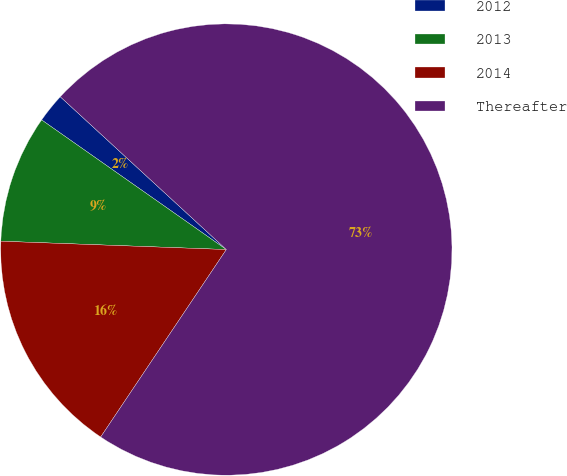Convert chart. <chart><loc_0><loc_0><loc_500><loc_500><pie_chart><fcel>2012<fcel>2013<fcel>2014<fcel>Thereafter<nl><fcel>2.1%<fcel>9.15%<fcel>16.19%<fcel>72.56%<nl></chart> 